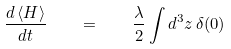<formula> <loc_0><loc_0><loc_500><loc_500>\frac { d \, \langle H \rangle } { d t } \quad = \quad \frac { \lambda } { 2 } \int d ^ { 3 } z \, \delta ( 0 )</formula> 